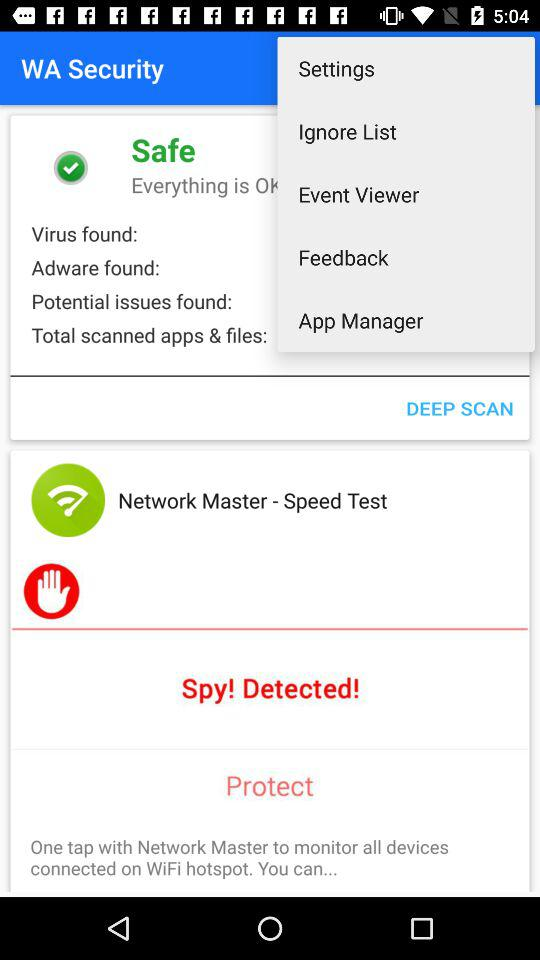What is the time? The time is 05:01 PM. 